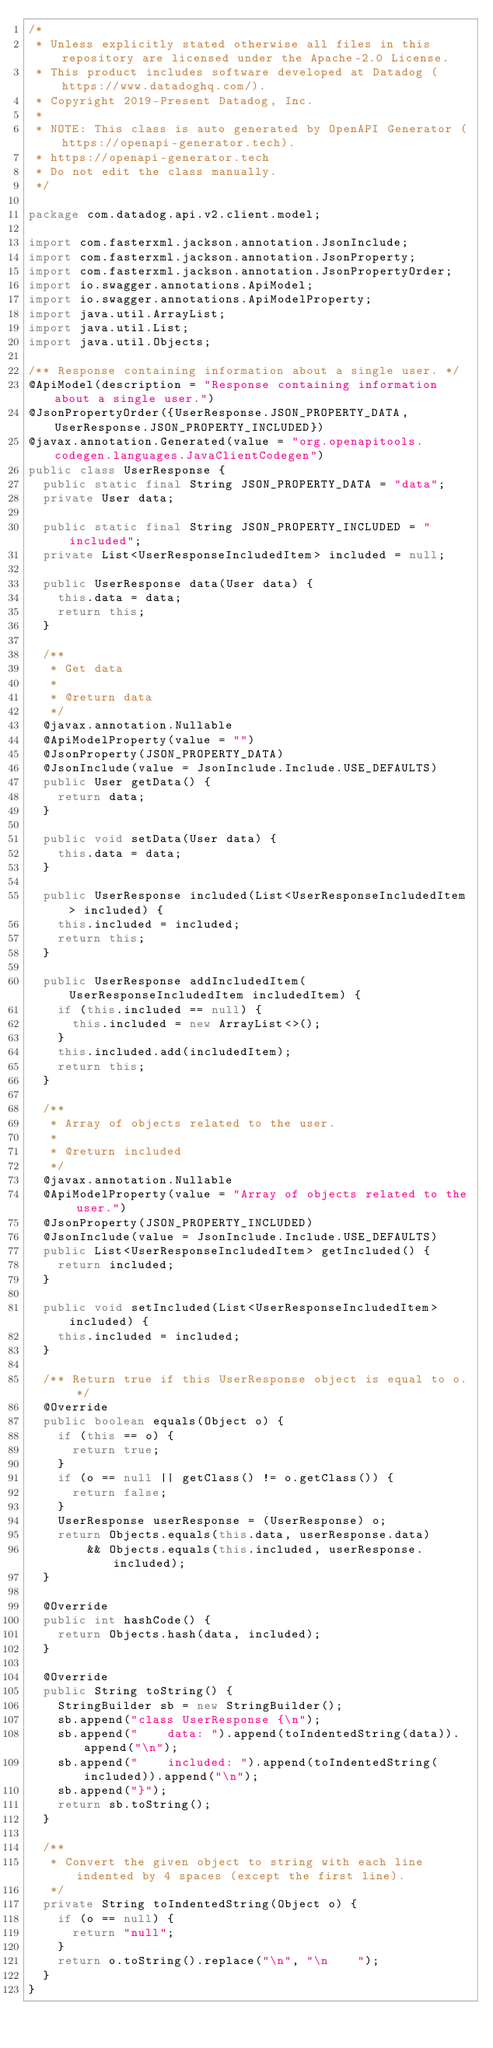Convert code to text. <code><loc_0><loc_0><loc_500><loc_500><_Java_>/*
 * Unless explicitly stated otherwise all files in this repository are licensed under the Apache-2.0 License.
 * This product includes software developed at Datadog (https://www.datadoghq.com/).
 * Copyright 2019-Present Datadog, Inc.
 *
 * NOTE: This class is auto generated by OpenAPI Generator (https://openapi-generator.tech).
 * https://openapi-generator.tech
 * Do not edit the class manually.
 */

package com.datadog.api.v2.client.model;

import com.fasterxml.jackson.annotation.JsonInclude;
import com.fasterxml.jackson.annotation.JsonProperty;
import com.fasterxml.jackson.annotation.JsonPropertyOrder;
import io.swagger.annotations.ApiModel;
import io.swagger.annotations.ApiModelProperty;
import java.util.ArrayList;
import java.util.List;
import java.util.Objects;

/** Response containing information about a single user. */
@ApiModel(description = "Response containing information about a single user.")
@JsonPropertyOrder({UserResponse.JSON_PROPERTY_DATA, UserResponse.JSON_PROPERTY_INCLUDED})
@javax.annotation.Generated(value = "org.openapitools.codegen.languages.JavaClientCodegen")
public class UserResponse {
  public static final String JSON_PROPERTY_DATA = "data";
  private User data;

  public static final String JSON_PROPERTY_INCLUDED = "included";
  private List<UserResponseIncludedItem> included = null;

  public UserResponse data(User data) {
    this.data = data;
    return this;
  }

  /**
   * Get data
   *
   * @return data
   */
  @javax.annotation.Nullable
  @ApiModelProperty(value = "")
  @JsonProperty(JSON_PROPERTY_DATA)
  @JsonInclude(value = JsonInclude.Include.USE_DEFAULTS)
  public User getData() {
    return data;
  }

  public void setData(User data) {
    this.data = data;
  }

  public UserResponse included(List<UserResponseIncludedItem> included) {
    this.included = included;
    return this;
  }

  public UserResponse addIncludedItem(UserResponseIncludedItem includedItem) {
    if (this.included == null) {
      this.included = new ArrayList<>();
    }
    this.included.add(includedItem);
    return this;
  }

  /**
   * Array of objects related to the user.
   *
   * @return included
   */
  @javax.annotation.Nullable
  @ApiModelProperty(value = "Array of objects related to the user.")
  @JsonProperty(JSON_PROPERTY_INCLUDED)
  @JsonInclude(value = JsonInclude.Include.USE_DEFAULTS)
  public List<UserResponseIncludedItem> getIncluded() {
    return included;
  }

  public void setIncluded(List<UserResponseIncludedItem> included) {
    this.included = included;
  }

  /** Return true if this UserResponse object is equal to o. */
  @Override
  public boolean equals(Object o) {
    if (this == o) {
      return true;
    }
    if (o == null || getClass() != o.getClass()) {
      return false;
    }
    UserResponse userResponse = (UserResponse) o;
    return Objects.equals(this.data, userResponse.data)
        && Objects.equals(this.included, userResponse.included);
  }

  @Override
  public int hashCode() {
    return Objects.hash(data, included);
  }

  @Override
  public String toString() {
    StringBuilder sb = new StringBuilder();
    sb.append("class UserResponse {\n");
    sb.append("    data: ").append(toIndentedString(data)).append("\n");
    sb.append("    included: ").append(toIndentedString(included)).append("\n");
    sb.append("}");
    return sb.toString();
  }

  /**
   * Convert the given object to string with each line indented by 4 spaces (except the first line).
   */
  private String toIndentedString(Object o) {
    if (o == null) {
      return "null";
    }
    return o.toString().replace("\n", "\n    ");
  }
}
</code> 